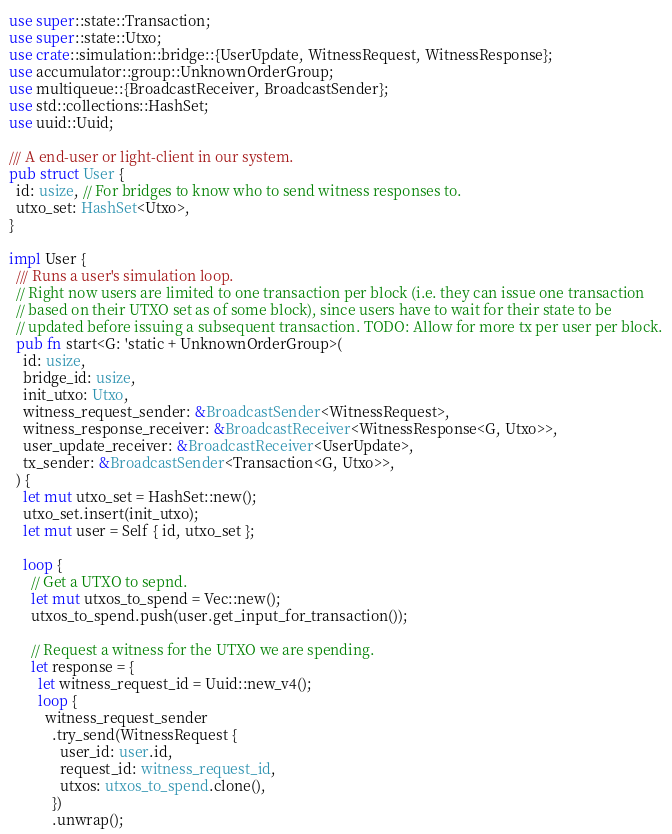Convert code to text. <code><loc_0><loc_0><loc_500><loc_500><_Rust_>use super::state::Transaction;
use super::state::Utxo;
use crate::simulation::bridge::{UserUpdate, WitnessRequest, WitnessResponse};
use accumulator::group::UnknownOrderGroup;
use multiqueue::{BroadcastReceiver, BroadcastSender};
use std::collections::HashSet;
use uuid::Uuid;

/// A end-user or light-client in our system.
pub struct User {
  id: usize, // For bridges to know who to send witness responses to.
  utxo_set: HashSet<Utxo>,
}

impl User {
  /// Runs a user's simulation loop.
  // Right now users are limited to one transaction per block (i.e. they can issue one transaction
  // based on their UTXO set as of some block), since users have to wait for their state to be
  // updated before issuing a subsequent transaction. TODO: Allow for more tx per user per block.
  pub fn start<G: 'static + UnknownOrderGroup>(
    id: usize,
    bridge_id: usize,
    init_utxo: Utxo,
    witness_request_sender: &BroadcastSender<WitnessRequest>,
    witness_response_receiver: &BroadcastReceiver<WitnessResponse<G, Utxo>>,
    user_update_receiver: &BroadcastReceiver<UserUpdate>,
    tx_sender: &BroadcastSender<Transaction<G, Utxo>>,
  ) {
    let mut utxo_set = HashSet::new();
    utxo_set.insert(init_utxo);
    let mut user = Self { id, utxo_set };

    loop {
      // Get a UTXO to sepnd.
      let mut utxos_to_spend = Vec::new();
      utxos_to_spend.push(user.get_input_for_transaction());

      // Request a witness for the UTXO we are spending.
      let response = {
        let witness_request_id = Uuid::new_v4();
        loop {
          witness_request_sender
            .try_send(WitnessRequest {
              user_id: user.id,
              request_id: witness_request_id,
              utxos: utxos_to_spend.clone(),
            })
            .unwrap();</code> 